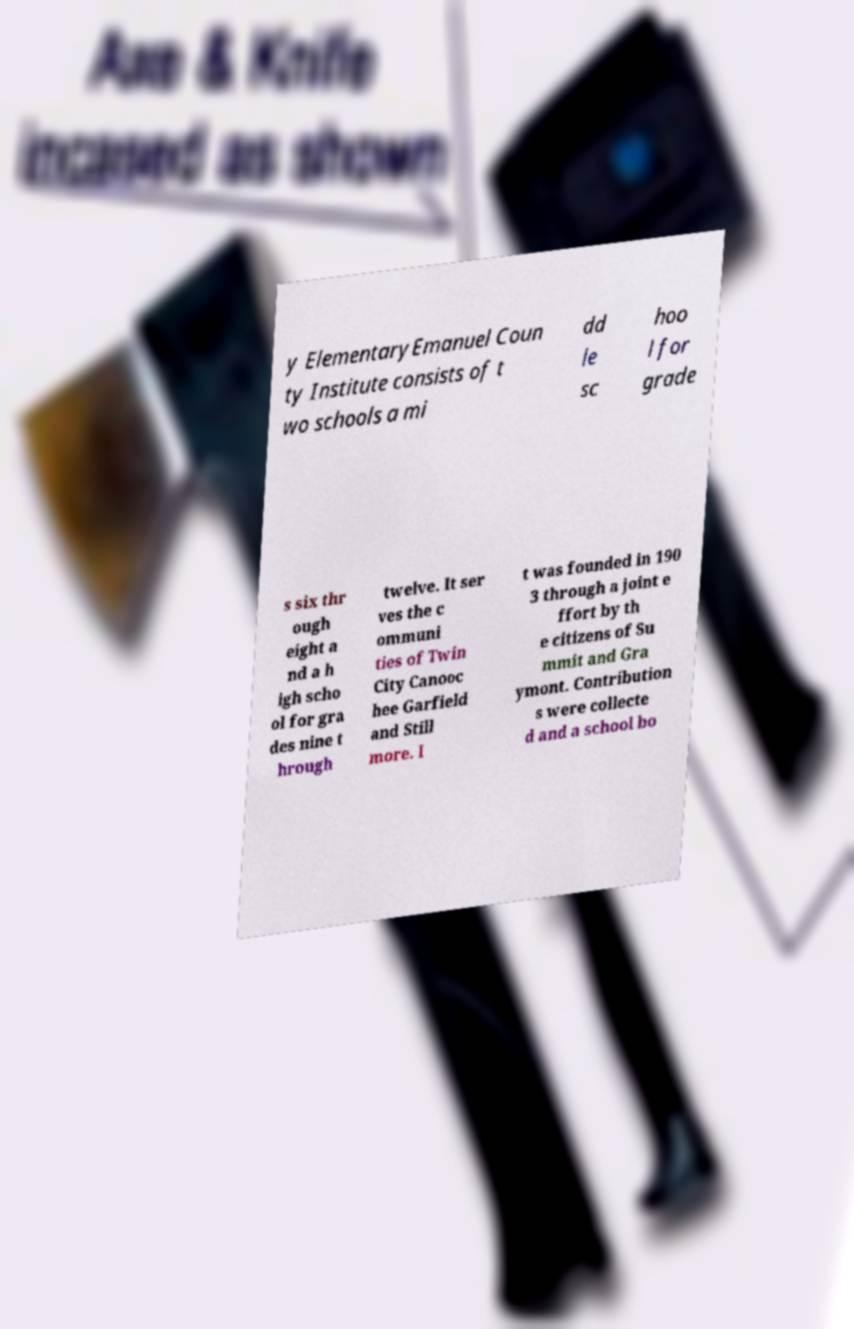Please identify and transcribe the text found in this image. y ElementaryEmanuel Coun ty Institute consists of t wo schools a mi dd le sc hoo l for grade s six thr ough eight a nd a h igh scho ol for gra des nine t hrough twelve. It ser ves the c ommuni ties of Twin City Canooc hee Garfield and Still more. I t was founded in 190 3 through a joint e ffort by th e citizens of Su mmit and Gra ymont. Contribution s were collecte d and a school bo 